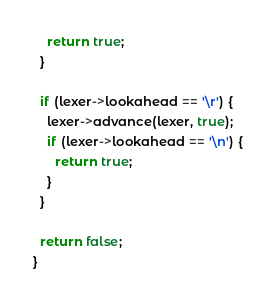Convert code to text. <code><loc_0><loc_0><loc_500><loc_500><_C_>    return true;
  }

  if (lexer->lookahead == '\r') {
    lexer->advance(lexer, true);
    if (lexer->lookahead == '\n') {
      return true;
    }
  }

  return false;
}
</code> 